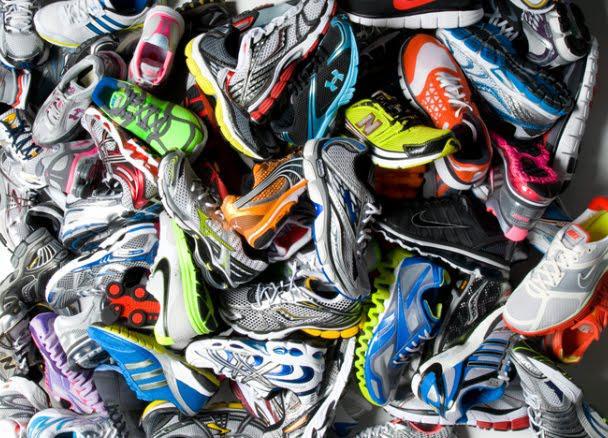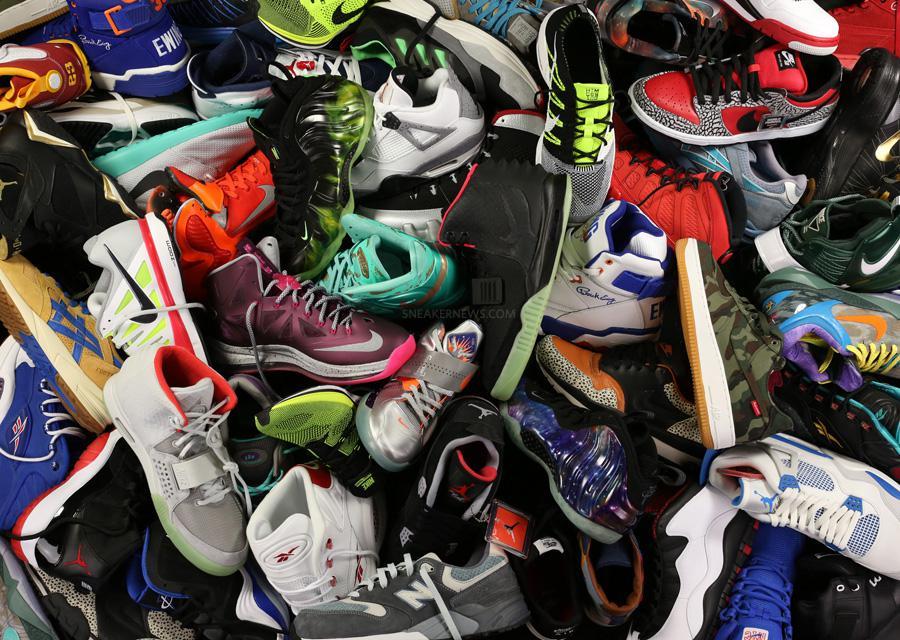The first image is the image on the left, the second image is the image on the right. Analyze the images presented: Is the assertion "At least 30 shoes are piled up and none are in neat rows." valid? Answer yes or no. Yes. 